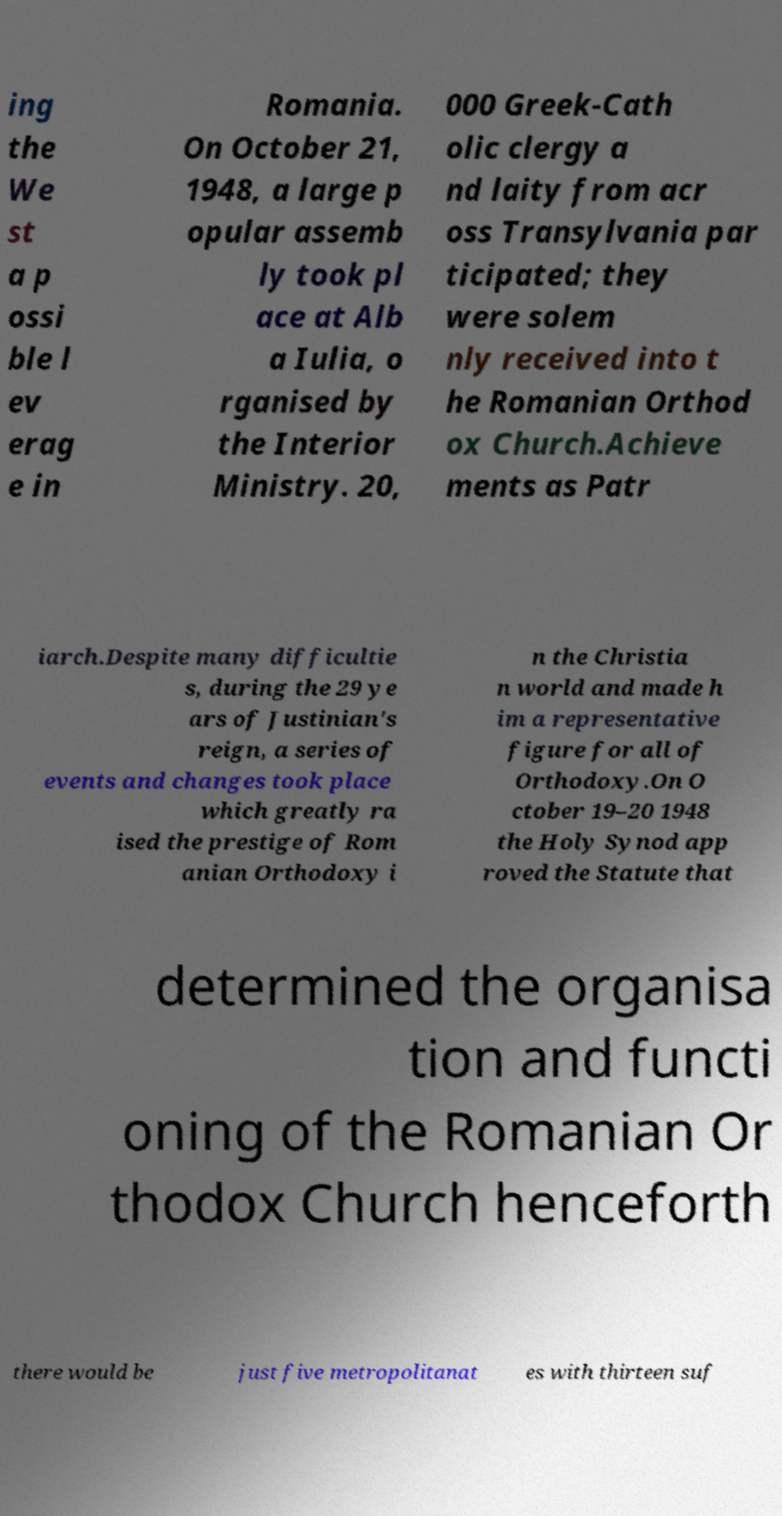Please identify and transcribe the text found in this image. ing the We st a p ossi ble l ev erag e in Romania. On October 21, 1948, a large p opular assemb ly took pl ace at Alb a Iulia, o rganised by the Interior Ministry. 20, 000 Greek-Cath olic clergy a nd laity from acr oss Transylvania par ticipated; they were solem nly received into t he Romanian Orthod ox Church.Achieve ments as Patr iarch.Despite many difficultie s, during the 29 ye ars of Justinian's reign, a series of events and changes took place which greatly ra ised the prestige of Rom anian Orthodoxy i n the Christia n world and made h im a representative figure for all of Orthodoxy.On O ctober 19–20 1948 the Holy Synod app roved the Statute that determined the organisa tion and functi oning of the Romanian Or thodox Church henceforth there would be just five metropolitanat es with thirteen suf 